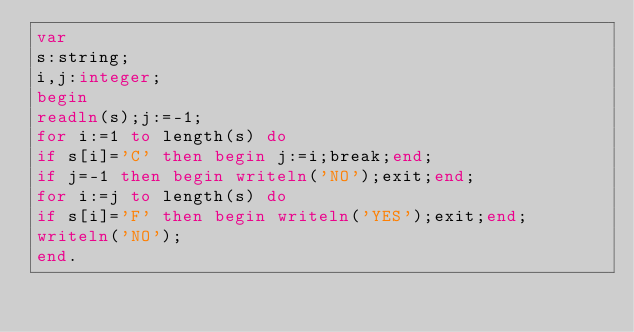<code> <loc_0><loc_0><loc_500><loc_500><_Pascal_>var
s:string;
i,j:integer;
begin
readln(s);j:=-1;
for i:=1 to length(s) do
if s[i]='C' then begin j:=i;break;end;
if j=-1 then begin writeln('NO');exit;end;
for i:=j to length(s) do
if s[i]='F' then begin writeln('YES');exit;end;
writeln('NO');
end.</code> 